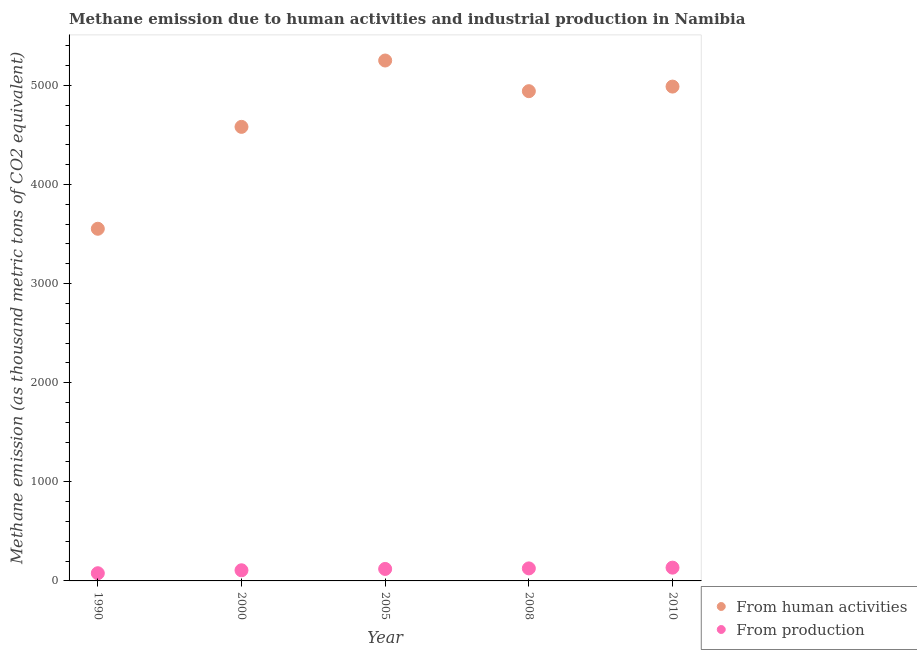How many different coloured dotlines are there?
Your answer should be very brief. 2. What is the amount of emissions generated from industries in 2005?
Offer a terse response. 121. Across all years, what is the maximum amount of emissions generated from industries?
Ensure brevity in your answer.  134. Across all years, what is the minimum amount of emissions from human activities?
Provide a succinct answer. 3553.5. In which year was the amount of emissions generated from industries maximum?
Make the answer very short. 2010. In which year was the amount of emissions from human activities minimum?
Give a very brief answer. 1990. What is the total amount of emissions from human activities in the graph?
Give a very brief answer. 2.33e+04. What is the difference between the amount of emissions from human activities in 1990 and that in 2010?
Offer a very short reply. -1434.7. What is the difference between the amount of emissions from human activities in 1990 and the amount of emissions generated from industries in 2008?
Ensure brevity in your answer.  3427.1. What is the average amount of emissions from human activities per year?
Give a very brief answer. 4663.32. In the year 2005, what is the difference between the amount of emissions generated from industries and amount of emissions from human activities?
Ensure brevity in your answer.  -5130.3. In how many years, is the amount of emissions from human activities greater than 1800 thousand metric tons?
Offer a terse response. 5. What is the ratio of the amount of emissions from human activities in 2008 to that in 2010?
Your answer should be very brief. 0.99. Is the amount of emissions from human activities in 2000 less than that in 2005?
Ensure brevity in your answer.  Yes. Is the difference between the amount of emissions generated from industries in 2000 and 2005 greater than the difference between the amount of emissions from human activities in 2000 and 2005?
Keep it short and to the point. Yes. What is the difference between the highest and the second highest amount of emissions from human activities?
Your answer should be compact. 263.1. What is the difference between the highest and the lowest amount of emissions from human activities?
Your response must be concise. 1697.8. Does the amount of emissions from human activities monotonically increase over the years?
Your answer should be very brief. No. How many dotlines are there?
Keep it short and to the point. 2. Does the graph contain any zero values?
Offer a very short reply. No. Where does the legend appear in the graph?
Your response must be concise. Bottom right. How many legend labels are there?
Your answer should be very brief. 2. What is the title of the graph?
Keep it short and to the point. Methane emission due to human activities and industrial production in Namibia. Does "Birth rate" appear as one of the legend labels in the graph?
Give a very brief answer. No. What is the label or title of the Y-axis?
Your answer should be compact. Methane emission (as thousand metric tons of CO2 equivalent). What is the Methane emission (as thousand metric tons of CO2 equivalent) of From human activities in 1990?
Your answer should be very brief. 3553.5. What is the Methane emission (as thousand metric tons of CO2 equivalent) of From production in 1990?
Ensure brevity in your answer.  77.6. What is the Methane emission (as thousand metric tons of CO2 equivalent) of From human activities in 2000?
Your response must be concise. 4581.7. What is the Methane emission (as thousand metric tons of CO2 equivalent) in From production in 2000?
Offer a very short reply. 107.4. What is the Methane emission (as thousand metric tons of CO2 equivalent) in From human activities in 2005?
Give a very brief answer. 5251.3. What is the Methane emission (as thousand metric tons of CO2 equivalent) in From production in 2005?
Your answer should be very brief. 121. What is the Methane emission (as thousand metric tons of CO2 equivalent) in From human activities in 2008?
Offer a very short reply. 4941.9. What is the Methane emission (as thousand metric tons of CO2 equivalent) in From production in 2008?
Your answer should be compact. 126.4. What is the Methane emission (as thousand metric tons of CO2 equivalent) in From human activities in 2010?
Your answer should be compact. 4988.2. What is the Methane emission (as thousand metric tons of CO2 equivalent) of From production in 2010?
Provide a succinct answer. 134. Across all years, what is the maximum Methane emission (as thousand metric tons of CO2 equivalent) in From human activities?
Offer a terse response. 5251.3. Across all years, what is the maximum Methane emission (as thousand metric tons of CO2 equivalent) of From production?
Provide a short and direct response. 134. Across all years, what is the minimum Methane emission (as thousand metric tons of CO2 equivalent) in From human activities?
Your answer should be very brief. 3553.5. Across all years, what is the minimum Methane emission (as thousand metric tons of CO2 equivalent) of From production?
Your answer should be compact. 77.6. What is the total Methane emission (as thousand metric tons of CO2 equivalent) in From human activities in the graph?
Keep it short and to the point. 2.33e+04. What is the total Methane emission (as thousand metric tons of CO2 equivalent) of From production in the graph?
Keep it short and to the point. 566.4. What is the difference between the Methane emission (as thousand metric tons of CO2 equivalent) of From human activities in 1990 and that in 2000?
Provide a short and direct response. -1028.2. What is the difference between the Methane emission (as thousand metric tons of CO2 equivalent) of From production in 1990 and that in 2000?
Your answer should be compact. -29.8. What is the difference between the Methane emission (as thousand metric tons of CO2 equivalent) of From human activities in 1990 and that in 2005?
Ensure brevity in your answer.  -1697.8. What is the difference between the Methane emission (as thousand metric tons of CO2 equivalent) in From production in 1990 and that in 2005?
Provide a short and direct response. -43.4. What is the difference between the Methane emission (as thousand metric tons of CO2 equivalent) in From human activities in 1990 and that in 2008?
Ensure brevity in your answer.  -1388.4. What is the difference between the Methane emission (as thousand metric tons of CO2 equivalent) in From production in 1990 and that in 2008?
Your answer should be very brief. -48.8. What is the difference between the Methane emission (as thousand metric tons of CO2 equivalent) in From human activities in 1990 and that in 2010?
Keep it short and to the point. -1434.7. What is the difference between the Methane emission (as thousand metric tons of CO2 equivalent) in From production in 1990 and that in 2010?
Your answer should be very brief. -56.4. What is the difference between the Methane emission (as thousand metric tons of CO2 equivalent) in From human activities in 2000 and that in 2005?
Give a very brief answer. -669.6. What is the difference between the Methane emission (as thousand metric tons of CO2 equivalent) in From human activities in 2000 and that in 2008?
Offer a very short reply. -360.2. What is the difference between the Methane emission (as thousand metric tons of CO2 equivalent) in From production in 2000 and that in 2008?
Your response must be concise. -19. What is the difference between the Methane emission (as thousand metric tons of CO2 equivalent) in From human activities in 2000 and that in 2010?
Keep it short and to the point. -406.5. What is the difference between the Methane emission (as thousand metric tons of CO2 equivalent) of From production in 2000 and that in 2010?
Ensure brevity in your answer.  -26.6. What is the difference between the Methane emission (as thousand metric tons of CO2 equivalent) in From human activities in 2005 and that in 2008?
Your answer should be compact. 309.4. What is the difference between the Methane emission (as thousand metric tons of CO2 equivalent) in From human activities in 2005 and that in 2010?
Your response must be concise. 263.1. What is the difference between the Methane emission (as thousand metric tons of CO2 equivalent) in From human activities in 2008 and that in 2010?
Offer a very short reply. -46.3. What is the difference between the Methane emission (as thousand metric tons of CO2 equivalent) of From human activities in 1990 and the Methane emission (as thousand metric tons of CO2 equivalent) of From production in 2000?
Your answer should be very brief. 3446.1. What is the difference between the Methane emission (as thousand metric tons of CO2 equivalent) of From human activities in 1990 and the Methane emission (as thousand metric tons of CO2 equivalent) of From production in 2005?
Provide a succinct answer. 3432.5. What is the difference between the Methane emission (as thousand metric tons of CO2 equivalent) in From human activities in 1990 and the Methane emission (as thousand metric tons of CO2 equivalent) in From production in 2008?
Offer a terse response. 3427.1. What is the difference between the Methane emission (as thousand metric tons of CO2 equivalent) of From human activities in 1990 and the Methane emission (as thousand metric tons of CO2 equivalent) of From production in 2010?
Provide a short and direct response. 3419.5. What is the difference between the Methane emission (as thousand metric tons of CO2 equivalent) of From human activities in 2000 and the Methane emission (as thousand metric tons of CO2 equivalent) of From production in 2005?
Provide a short and direct response. 4460.7. What is the difference between the Methane emission (as thousand metric tons of CO2 equivalent) in From human activities in 2000 and the Methane emission (as thousand metric tons of CO2 equivalent) in From production in 2008?
Make the answer very short. 4455.3. What is the difference between the Methane emission (as thousand metric tons of CO2 equivalent) of From human activities in 2000 and the Methane emission (as thousand metric tons of CO2 equivalent) of From production in 2010?
Offer a terse response. 4447.7. What is the difference between the Methane emission (as thousand metric tons of CO2 equivalent) in From human activities in 2005 and the Methane emission (as thousand metric tons of CO2 equivalent) in From production in 2008?
Your answer should be compact. 5124.9. What is the difference between the Methane emission (as thousand metric tons of CO2 equivalent) in From human activities in 2005 and the Methane emission (as thousand metric tons of CO2 equivalent) in From production in 2010?
Offer a terse response. 5117.3. What is the difference between the Methane emission (as thousand metric tons of CO2 equivalent) of From human activities in 2008 and the Methane emission (as thousand metric tons of CO2 equivalent) of From production in 2010?
Provide a short and direct response. 4807.9. What is the average Methane emission (as thousand metric tons of CO2 equivalent) of From human activities per year?
Give a very brief answer. 4663.32. What is the average Methane emission (as thousand metric tons of CO2 equivalent) of From production per year?
Your response must be concise. 113.28. In the year 1990, what is the difference between the Methane emission (as thousand metric tons of CO2 equivalent) of From human activities and Methane emission (as thousand metric tons of CO2 equivalent) of From production?
Offer a terse response. 3475.9. In the year 2000, what is the difference between the Methane emission (as thousand metric tons of CO2 equivalent) of From human activities and Methane emission (as thousand metric tons of CO2 equivalent) of From production?
Ensure brevity in your answer.  4474.3. In the year 2005, what is the difference between the Methane emission (as thousand metric tons of CO2 equivalent) of From human activities and Methane emission (as thousand metric tons of CO2 equivalent) of From production?
Your answer should be very brief. 5130.3. In the year 2008, what is the difference between the Methane emission (as thousand metric tons of CO2 equivalent) of From human activities and Methane emission (as thousand metric tons of CO2 equivalent) of From production?
Offer a very short reply. 4815.5. In the year 2010, what is the difference between the Methane emission (as thousand metric tons of CO2 equivalent) in From human activities and Methane emission (as thousand metric tons of CO2 equivalent) in From production?
Your response must be concise. 4854.2. What is the ratio of the Methane emission (as thousand metric tons of CO2 equivalent) of From human activities in 1990 to that in 2000?
Keep it short and to the point. 0.78. What is the ratio of the Methane emission (as thousand metric tons of CO2 equivalent) of From production in 1990 to that in 2000?
Give a very brief answer. 0.72. What is the ratio of the Methane emission (as thousand metric tons of CO2 equivalent) in From human activities in 1990 to that in 2005?
Ensure brevity in your answer.  0.68. What is the ratio of the Methane emission (as thousand metric tons of CO2 equivalent) of From production in 1990 to that in 2005?
Keep it short and to the point. 0.64. What is the ratio of the Methane emission (as thousand metric tons of CO2 equivalent) of From human activities in 1990 to that in 2008?
Your response must be concise. 0.72. What is the ratio of the Methane emission (as thousand metric tons of CO2 equivalent) in From production in 1990 to that in 2008?
Offer a terse response. 0.61. What is the ratio of the Methane emission (as thousand metric tons of CO2 equivalent) in From human activities in 1990 to that in 2010?
Ensure brevity in your answer.  0.71. What is the ratio of the Methane emission (as thousand metric tons of CO2 equivalent) of From production in 1990 to that in 2010?
Give a very brief answer. 0.58. What is the ratio of the Methane emission (as thousand metric tons of CO2 equivalent) of From human activities in 2000 to that in 2005?
Offer a very short reply. 0.87. What is the ratio of the Methane emission (as thousand metric tons of CO2 equivalent) in From production in 2000 to that in 2005?
Keep it short and to the point. 0.89. What is the ratio of the Methane emission (as thousand metric tons of CO2 equivalent) of From human activities in 2000 to that in 2008?
Offer a terse response. 0.93. What is the ratio of the Methane emission (as thousand metric tons of CO2 equivalent) in From production in 2000 to that in 2008?
Provide a succinct answer. 0.85. What is the ratio of the Methane emission (as thousand metric tons of CO2 equivalent) in From human activities in 2000 to that in 2010?
Your response must be concise. 0.92. What is the ratio of the Methane emission (as thousand metric tons of CO2 equivalent) of From production in 2000 to that in 2010?
Provide a short and direct response. 0.8. What is the ratio of the Methane emission (as thousand metric tons of CO2 equivalent) of From human activities in 2005 to that in 2008?
Give a very brief answer. 1.06. What is the ratio of the Methane emission (as thousand metric tons of CO2 equivalent) of From production in 2005 to that in 2008?
Provide a short and direct response. 0.96. What is the ratio of the Methane emission (as thousand metric tons of CO2 equivalent) of From human activities in 2005 to that in 2010?
Provide a succinct answer. 1.05. What is the ratio of the Methane emission (as thousand metric tons of CO2 equivalent) of From production in 2005 to that in 2010?
Give a very brief answer. 0.9. What is the ratio of the Methane emission (as thousand metric tons of CO2 equivalent) of From human activities in 2008 to that in 2010?
Make the answer very short. 0.99. What is the ratio of the Methane emission (as thousand metric tons of CO2 equivalent) of From production in 2008 to that in 2010?
Your response must be concise. 0.94. What is the difference between the highest and the second highest Methane emission (as thousand metric tons of CO2 equivalent) in From human activities?
Make the answer very short. 263.1. What is the difference between the highest and the second highest Methane emission (as thousand metric tons of CO2 equivalent) in From production?
Ensure brevity in your answer.  7.6. What is the difference between the highest and the lowest Methane emission (as thousand metric tons of CO2 equivalent) of From human activities?
Your response must be concise. 1697.8. What is the difference between the highest and the lowest Methane emission (as thousand metric tons of CO2 equivalent) in From production?
Offer a terse response. 56.4. 